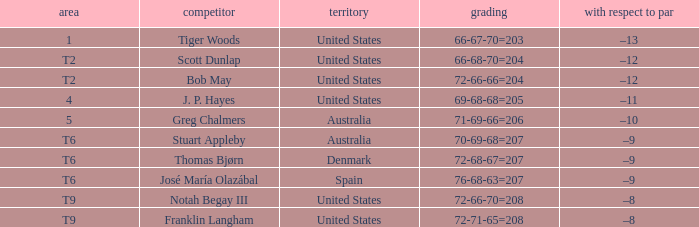What country is player thomas bjørn from? Denmark. 